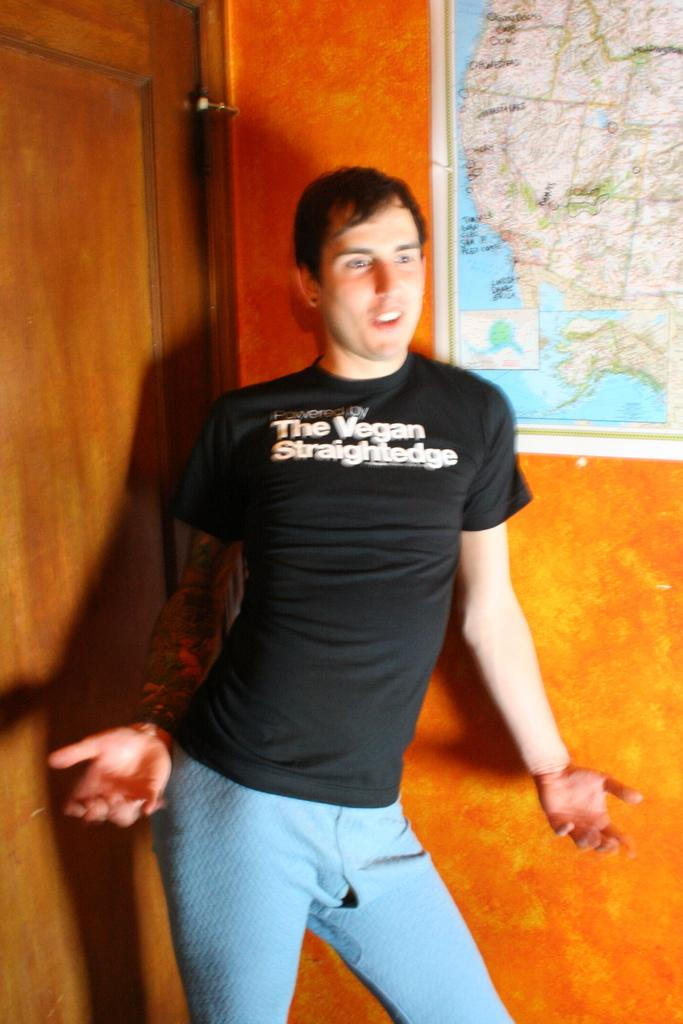<image>
Present a compact description of the photo's key features. A man with a black shirt that says "Powered by The Vegan Straightedge" 